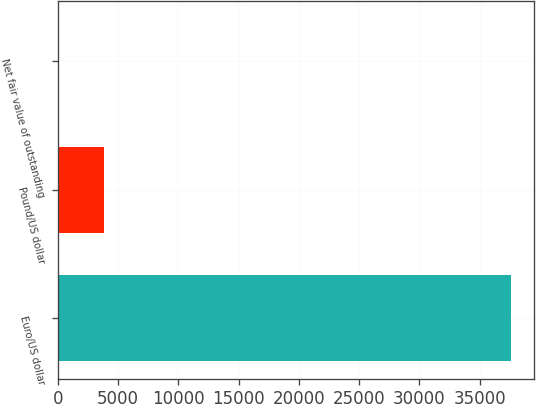Convert chart to OTSL. <chart><loc_0><loc_0><loc_500><loc_500><bar_chart><fcel>Euro/US dollar<fcel>Pound/US dollar<fcel>Net fair value of outstanding<nl><fcel>37598<fcel>3810<fcel>18<nl></chart> 